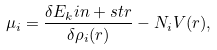<formula> <loc_0><loc_0><loc_500><loc_500>\mu _ { i } = \frac { \delta E _ { k } i n + s t r } { \delta \rho _ { i } ( { r } ) } - N _ { i } V ( { r } ) ,</formula> 